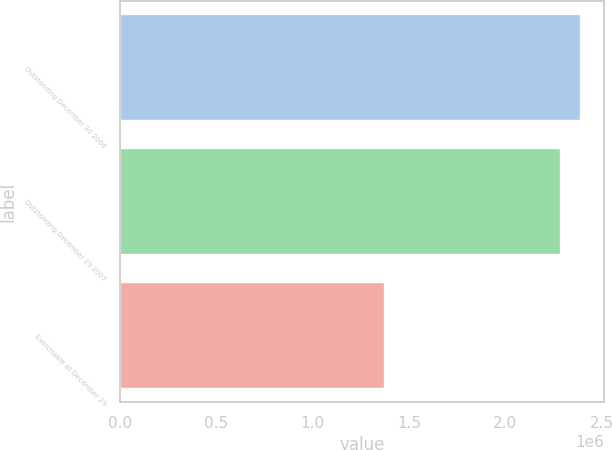Convert chart. <chart><loc_0><loc_0><loc_500><loc_500><bar_chart><fcel>Outstanding December 30 2006<fcel>Outstanding December 29 2007<fcel>Exercisable at December 29<nl><fcel>2.39136e+06<fcel>2.28833e+06<fcel>1.37374e+06<nl></chart> 